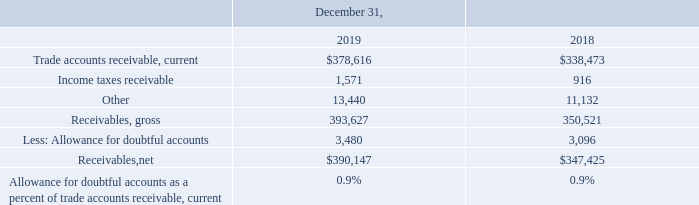Note 9. Receivables, Net
Receivables, net consisted of the following (in thousands):
What was the amount for Other in 2019?
Answer scale should be: thousand. 13,440. What was the amount for  Receivables, gross in 2018?
Answer scale should be: thousand. 350,521. In which years is the amount of Receivables, net calculated? 2019, 2018. In which year was the amount of Less: Allowance for doubtful accounts larger? 3,480>3,096
Answer: 2019. What was the change in Income taxes receivable in 2019 from 2018?
Answer scale should be: thousand. 1,571-916
Answer: 655. What was the percentage change in Income taxes receivable in 2019 from 2018?
Answer scale should be: percent. (1,571-916)/916
Answer: 71.51. 